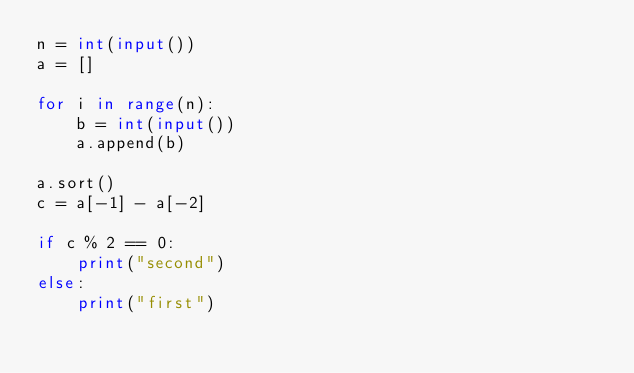<code> <loc_0><loc_0><loc_500><loc_500><_Python_>n = int(input())
a = []

for i in range(n):
    b = int(input())
    a.append(b)

a.sort()
c = a[-1] - a[-2]

if c % 2 == 0:
    print("second")
else:
    print("first")</code> 